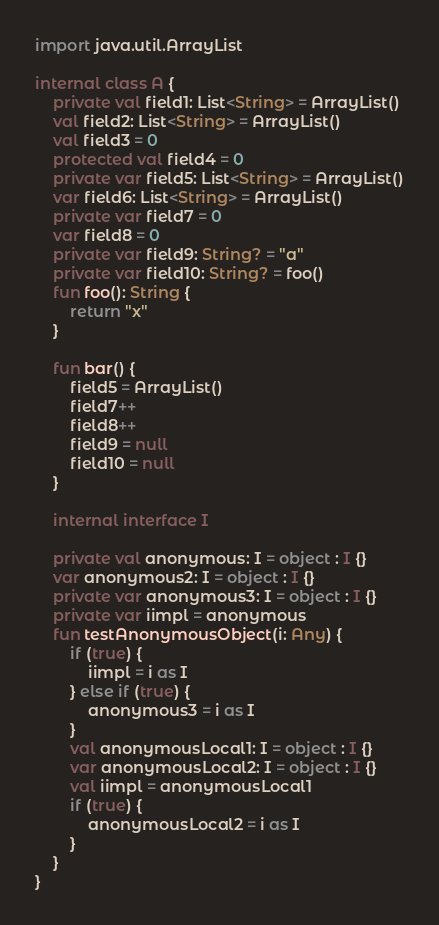Convert code to text. <code><loc_0><loc_0><loc_500><loc_500><_Kotlin_>import java.util.ArrayList

internal class A {
    private val field1: List<String> = ArrayList()
    val field2: List<String> = ArrayList()
    val field3 = 0
    protected val field4 = 0
    private var field5: List<String> = ArrayList()
    var field6: List<String> = ArrayList()
    private var field7 = 0
    var field8 = 0
    private var field9: String? = "a"
    private var field10: String? = foo()
    fun foo(): String {
        return "x"
    }

    fun bar() {
        field5 = ArrayList()
        field7++
        field8++
        field9 = null
        field10 = null
    }

    internal interface I

    private val anonymous: I = object : I {}
    var anonymous2: I = object : I {}
    private var anonymous3: I = object : I {}
    private var iimpl = anonymous
    fun testAnonymousObject(i: Any) {
        if (true) {
            iimpl = i as I
        } else if (true) {
            anonymous3 = i as I
        }
        val anonymousLocal1: I = object : I {}
        var anonymousLocal2: I = object : I {}
        val iimpl = anonymousLocal1
        if (true) {
            anonymousLocal2 = i as I
        }
    }
}</code> 